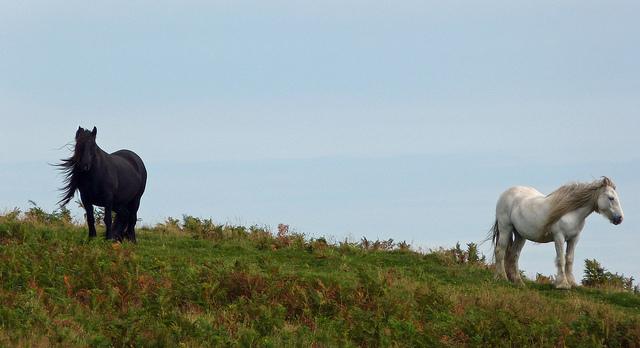Are the horses on a hill?
Keep it brief. Yes. Are the horses near a body of water?
Short answer required. No. What kind of animal is this?
Short answer required. Horse. How many animals are there?
Answer briefly. 2. How many animals are roaming?
Be succinct. 2. How many horses are in the field?
Concise answer only. 2. What is that black animal?
Keep it brief. Horse. What is barricading the horses?
Give a very brief answer. Nothing. What color are these horses?
Write a very short answer. White and black. Are these horses the same color?
Quick response, please. No. What color is the horse?
Concise answer only. White. Are the horses walking towards one another?
Answer briefly. No. How many horse ears are in the image?
Answer briefly. 4. Who is looking at the horse?
Keep it brief. Photographer. 